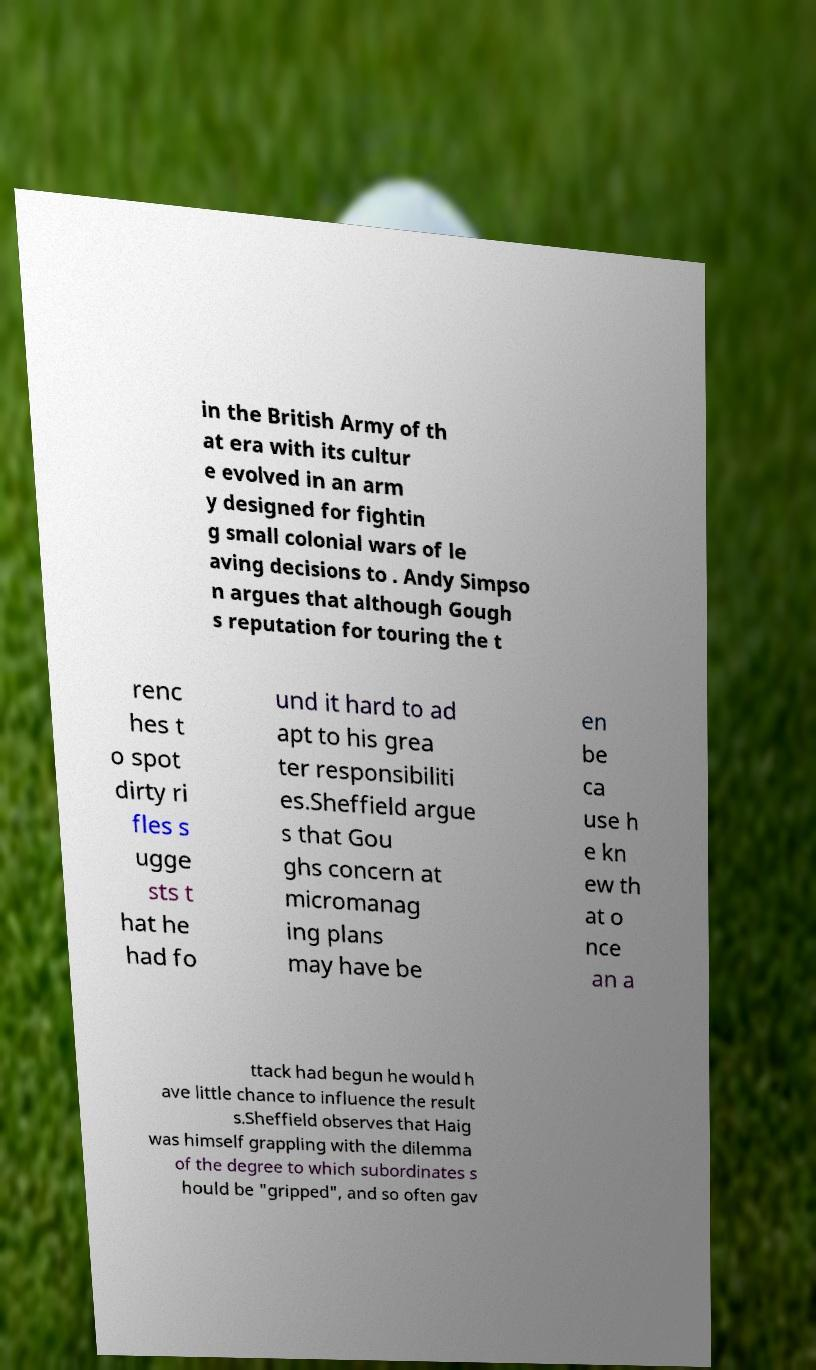Can you read and provide the text displayed in the image?This photo seems to have some interesting text. Can you extract and type it out for me? in the British Army of th at era with its cultur e evolved in an arm y designed for fightin g small colonial wars of le aving decisions to . Andy Simpso n argues that although Gough s reputation for touring the t renc hes t o spot dirty ri fles s ugge sts t hat he had fo und it hard to ad apt to his grea ter responsibiliti es.Sheffield argue s that Gou ghs concern at micromanag ing plans may have be en be ca use h e kn ew th at o nce an a ttack had begun he would h ave little chance to influence the result s.Sheffield observes that Haig was himself grappling with the dilemma of the degree to which subordinates s hould be "gripped", and so often gav 